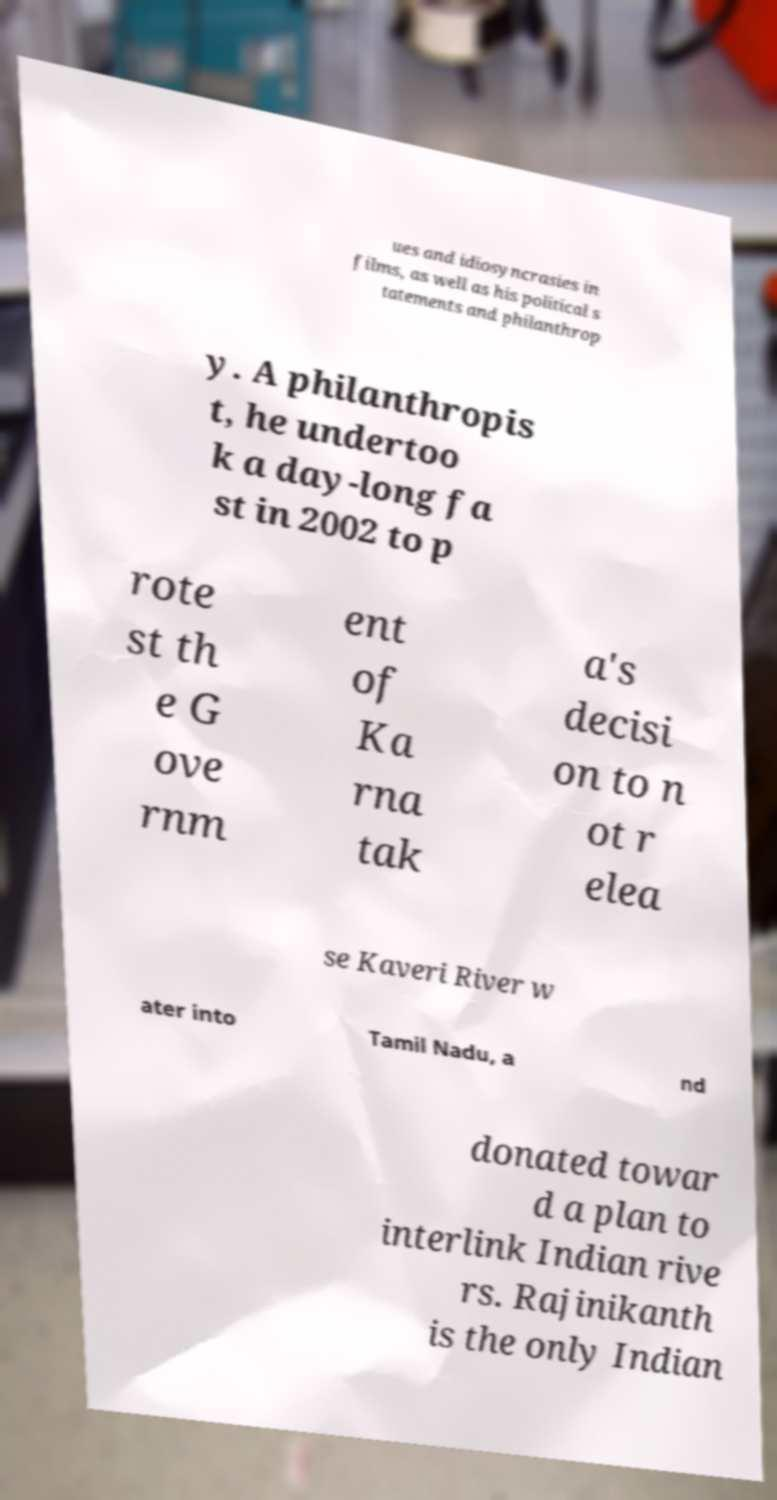Could you extract and type out the text from this image? ues and idiosyncrasies in films, as well as his political s tatements and philanthrop y. A philanthropis t, he undertoo k a day-long fa st in 2002 to p rote st th e G ove rnm ent of Ka rna tak a's decisi on to n ot r elea se Kaveri River w ater into Tamil Nadu, a nd donated towar d a plan to interlink Indian rive rs. Rajinikanth is the only Indian 